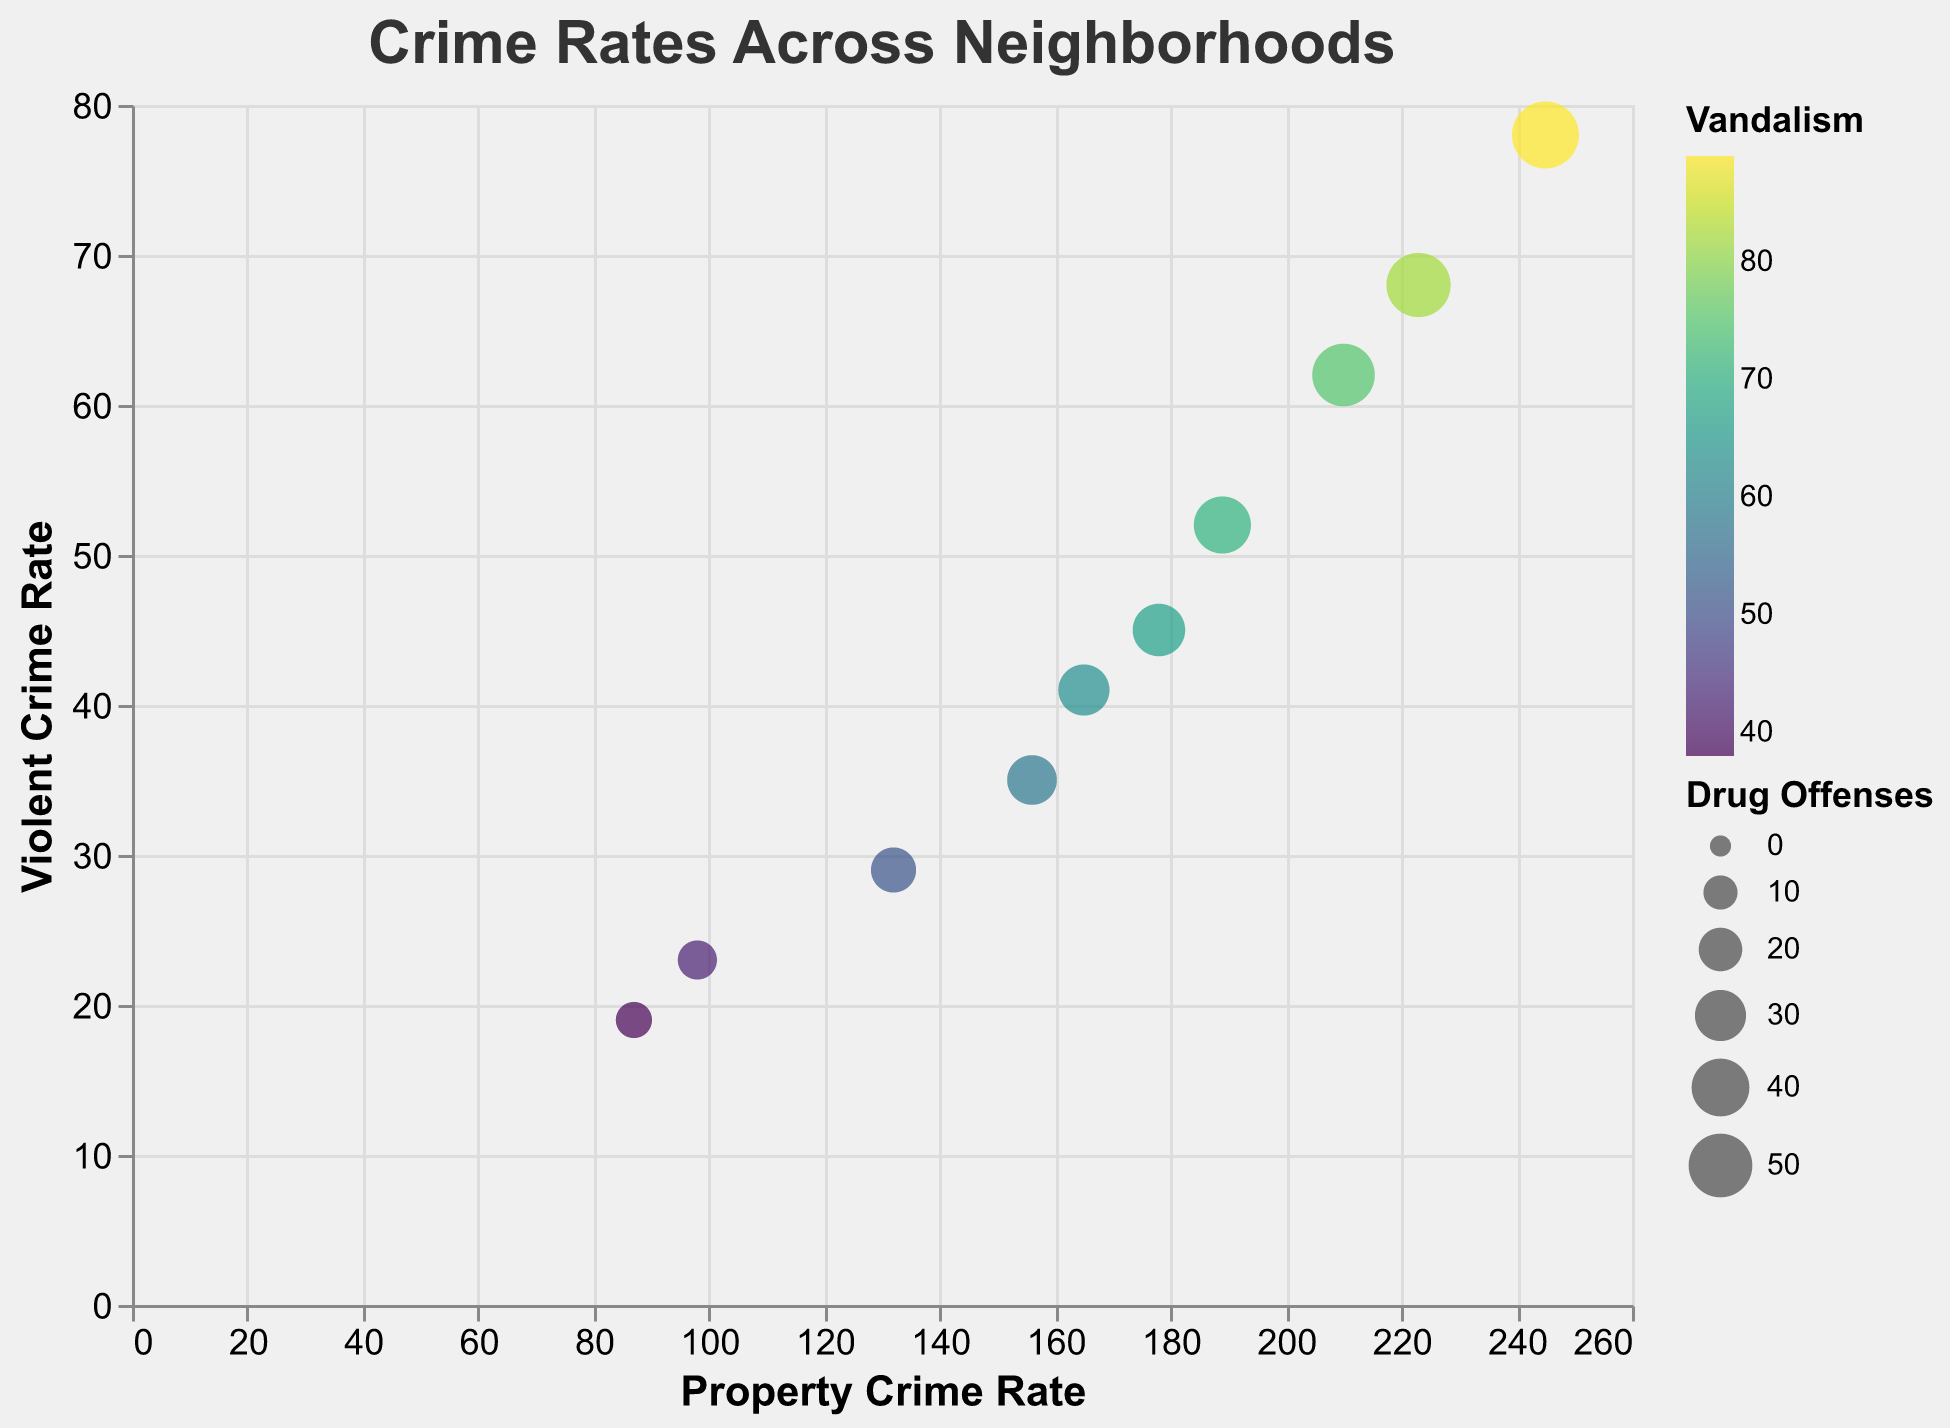How many neighborhoods have both their violent crime and property crime rates below 50? Analyze the plot and count the neighborhoods where both the violent crime and property crime rates are below 50. Neighborhoods within these criteria are Elmdale, Sunnyside, and Westview.
Answer: 3 Which neighborhood has the highest rate of violent crime? Look at the figure and find the neighborhood with the highest dot on the y-axis that represents violent crime rates. Downtown has the highest violent crime rate with 78.
Answer: Downtown What's the range of property crime rates? Refer to the x-axis which represents property crime rates and identify the minimum and maximum values. The neighborhood with the lowest property crime rate is Westview (87) and the highest is Downtown (245). So, the range is 245 - 87 = 158.
Answer: 158 Are there any neighborhoods with more than 200 property crimes and less than 40 violent crimes? If yes, which ones? Check the x-axis (property crime rate) to find values greater than 200 and cross-reference these with the y-axis (violent crime rate) for values less than 40. None of the neighborhoods fit this criteria.
Answer: No Which neighborhood has the largest number of drug offenses? Refer to the size of the circles in the figure which encode drug offenses. The largest circle represents Downtown which has 56 drug offenses.
Answer: Downtown What's the relationship between violent crime and vandalism rates in neighborhoods? Analyze the plot for how color (vandalism rate) varies with y-axis values (violent crime rates). Generally, neighborhoods with higher violent crime rates also have higher vandalism rates, as seen by darker colors corresponding to higher y-axis values.
Answer: Positive correlation Which neighborhood shows the least amount of vandalism? Look for the circle with the lightest color, representing the lowest vandalism rate, which is Westview with a rate of 38.
Answer: Westview What is the average property crime rate among the top three neighborhoods with the highest violent crime rates? First, identify the top three neighborhoods for violent crime (Downtown, Fairmont, and Riverside), then sum their property crime rates (245 + 223 + 210) which equals 678. Divide by 3 to get 226.
Answer: 226 Which neighborhoods have property crime rates greater than 150 and also have drug offenses greater than 40? Look at circles in the plot which are positioned beyond 150 on the x-axis (property crime) and have large sizes (indicating drug offenses > 40). The neighborhoods are Downtown, Riverside, Fairmont, and Maplewood.
Answer: Downtown, Riverside, Fairmont, Maplewood 